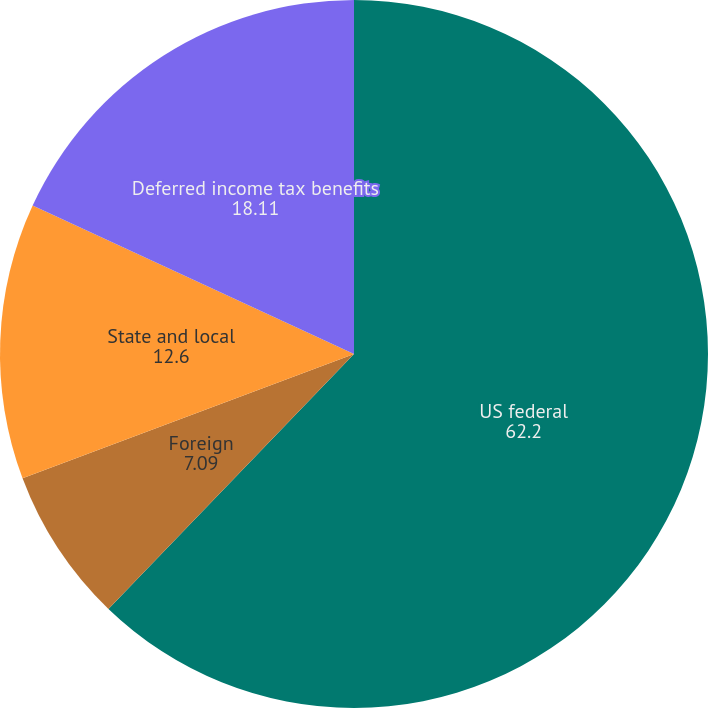Convert chart to OTSL. <chart><loc_0><loc_0><loc_500><loc_500><pie_chart><fcel>US federal<fcel>Foreign<fcel>State and local<fcel>Deferred income tax benefits<nl><fcel>62.2%<fcel>7.09%<fcel>12.6%<fcel>18.11%<nl></chart> 